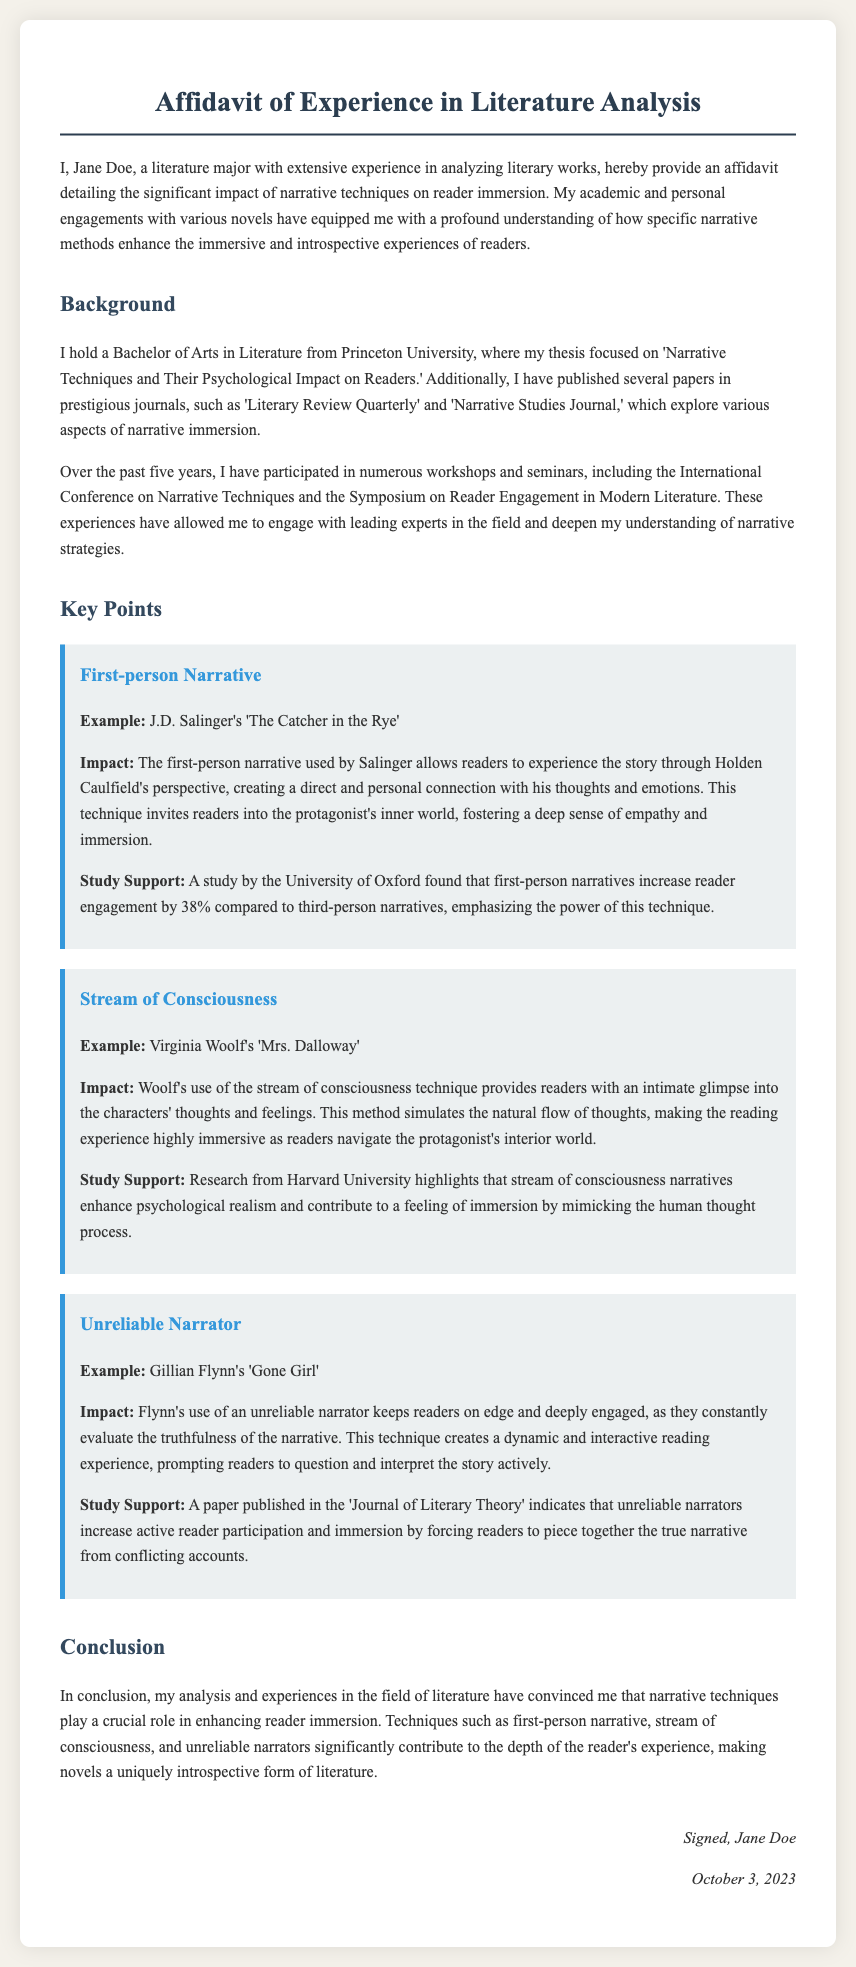What is the full name of the author? The author of the affidavit is Jane Doe, as stated at the beginning of the document.
Answer: Jane Doe What major did the author study? The author specifies that they are a literature major, which indicates their field of study.
Answer: Literature What university did the author attend? The affidavit mentions that the author holds a Bachelor of Arts from Princeton University.
Answer: Princeton University What technique is highlighted in relation to "The Catcher in the Rye"? The document refers to a specific narrative technique associated with J.D. Salinger's novel.
Answer: First-person narrative How much does first-person narrative increase reader engagement? The document cites a study indicating a specific percentage increase in engagement with first-person narratives compared to third-person.
Answer: 38% What narrative technique does Virginia Woolf use in "Mrs. Dalloway"? The affidavit identifies a specific narrative technique employed by Woolf in her work.
Answer: Stream of consciousness What is the publication date of the affidavit? The author provides a specific date at the end of the document indicating when the affidavit was signed.
Answer: October 3, 2023 What effect does an unreliable narrator have on readers? The affidavit states a specific impact that unreliable narrators have on reader participation and engagement.
Answer: Active reader participation What is the primary conclusion drawn in the affidavit? The author concludes that narrative techniques are crucial for enhancing a specific aspect of the reading experience.
Answer: Reader immersion 